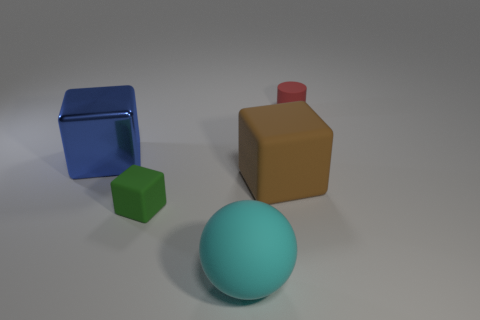There is a matte cylinder that is the same size as the green thing; what is its color?
Your answer should be compact. Red. How many things are either small things in front of the tiny cylinder or large green cylinders?
Your response must be concise. 1. There is a cube that is both left of the brown matte thing and behind the tiny green block; what is its size?
Offer a terse response. Large. How many other things are there of the same size as the cyan rubber thing?
Give a very brief answer. 2. There is a cube on the right side of the tiny matte thing to the left of the object that is behind the blue thing; what is its color?
Make the answer very short. Brown. The object that is both behind the big rubber cube and in front of the small red object has what shape?
Offer a very short reply. Cube. How many other things are the same shape as the blue metal object?
Your answer should be compact. 2. What is the shape of the small matte object that is to the right of the tiny object that is to the left of the tiny object that is behind the big blue thing?
Provide a short and direct response. Cylinder. What number of objects are either large cyan rubber balls or objects on the left side of the sphere?
Your answer should be compact. 3. Is the shape of the small thing that is in front of the matte cylinder the same as the large matte object that is behind the cyan matte sphere?
Give a very brief answer. Yes. 